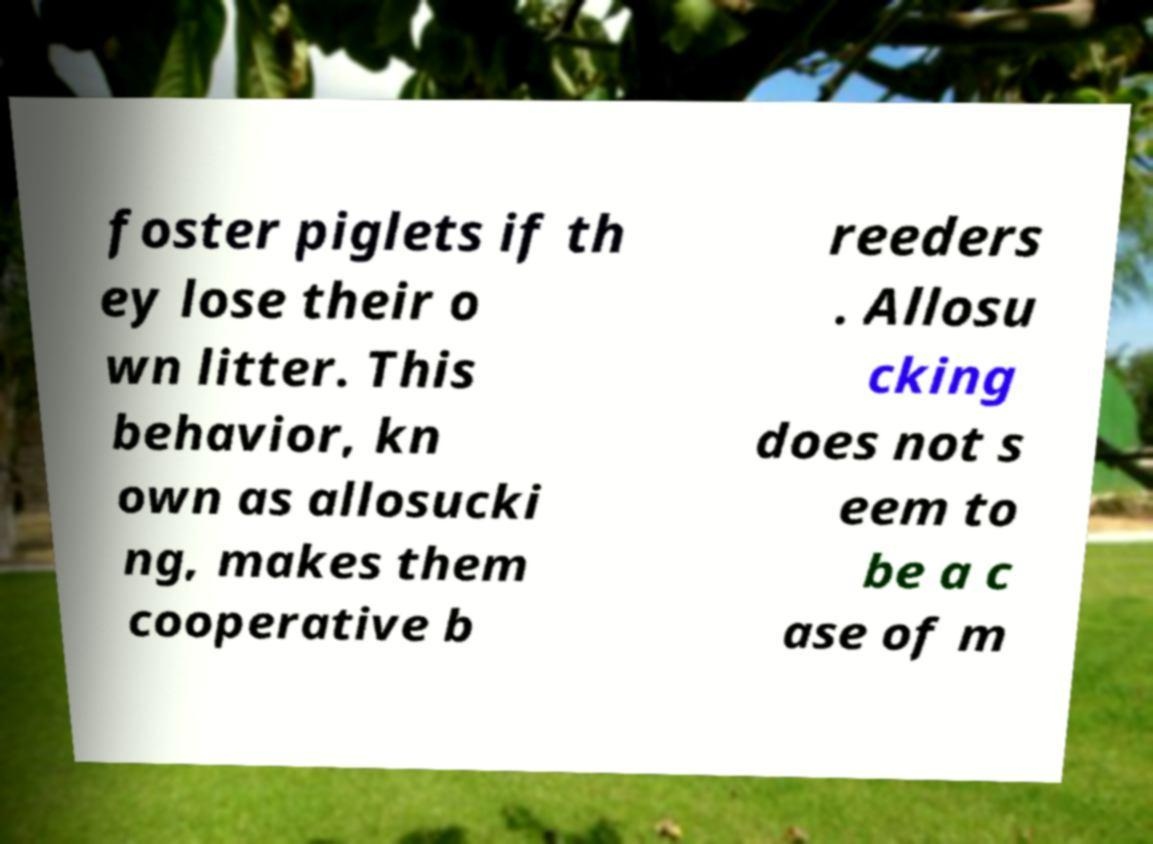Please read and relay the text visible in this image. What does it say? foster piglets if th ey lose their o wn litter. This behavior, kn own as allosucki ng, makes them cooperative b reeders . Allosu cking does not s eem to be a c ase of m 